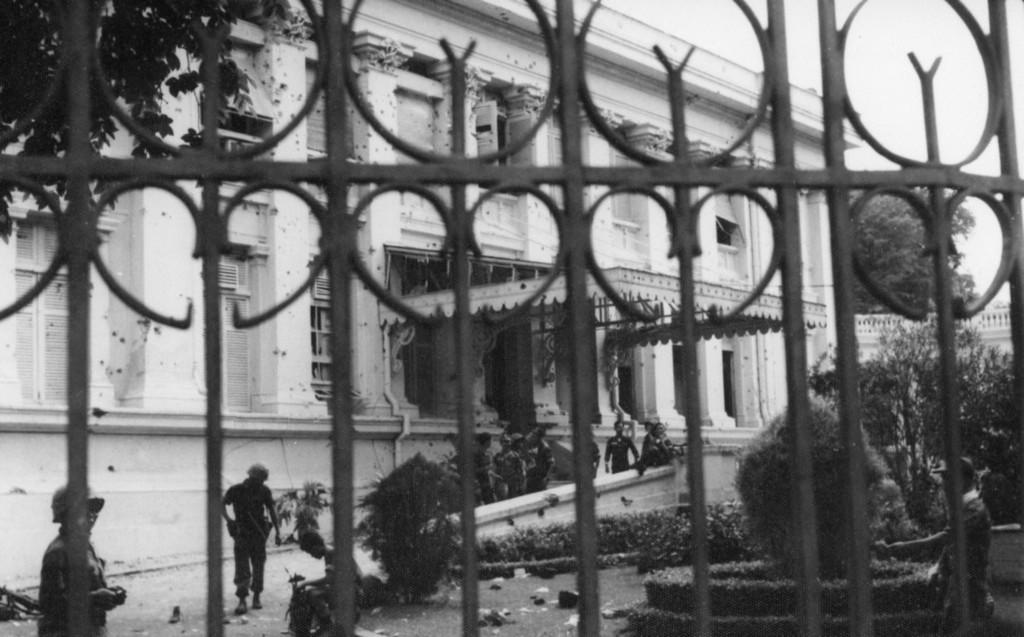What is located in the foreground of the image? In the foreground of the image, there is a fence, plants, trees, and a group of people on the road. Can you describe the vegetation in the foreground of the image? The vegetation in the foreground includes plants and trees. What can be seen in the background of the image? In the background of the image, there is a building with visible windows, and the sky is also visible. When was the image taken? The image was taken during the day. How many twists are there in the fence in the image? There is no mention of twists in the fence in the provided facts, so we cannot determine the number of twists. Can you tell me the size of the judge in the image? There is no judge present in the image, so we cannot determine the size of a judge. 